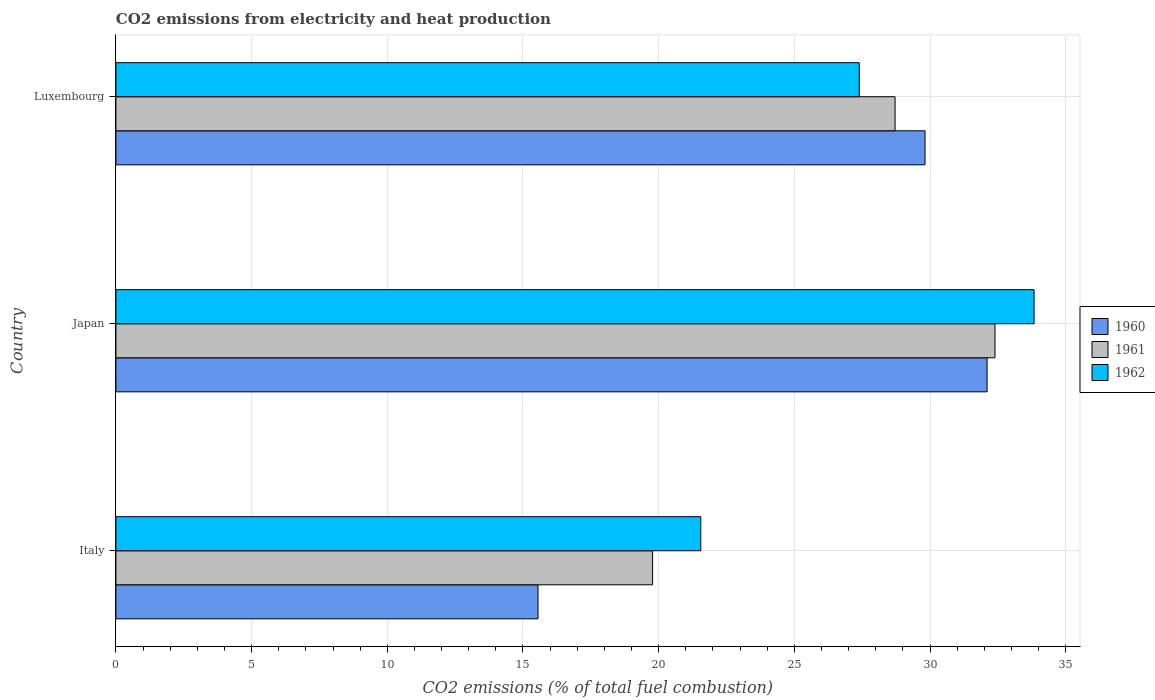How many groups of bars are there?
Your answer should be compact. 3. Are the number of bars per tick equal to the number of legend labels?
Offer a terse response. Yes. How many bars are there on the 3rd tick from the top?
Make the answer very short. 3. How many bars are there on the 2nd tick from the bottom?
Your answer should be compact. 3. What is the label of the 3rd group of bars from the top?
Your answer should be very brief. Italy. In how many cases, is the number of bars for a given country not equal to the number of legend labels?
Provide a short and direct response. 0. What is the amount of CO2 emitted in 1962 in Luxembourg?
Give a very brief answer. 27.39. Across all countries, what is the maximum amount of CO2 emitted in 1960?
Give a very brief answer. 32.1. Across all countries, what is the minimum amount of CO2 emitted in 1960?
Provide a short and direct response. 15.55. In which country was the amount of CO2 emitted in 1962 maximum?
Make the answer very short. Japan. What is the total amount of CO2 emitted in 1962 in the graph?
Your answer should be very brief. 82.78. What is the difference between the amount of CO2 emitted in 1960 in Italy and that in Japan?
Ensure brevity in your answer.  -16.55. What is the difference between the amount of CO2 emitted in 1960 in Italy and the amount of CO2 emitted in 1961 in Japan?
Your answer should be compact. -16.84. What is the average amount of CO2 emitted in 1962 per country?
Offer a terse response. 27.59. What is the difference between the amount of CO2 emitted in 1960 and amount of CO2 emitted in 1962 in Luxembourg?
Ensure brevity in your answer.  2.42. In how many countries, is the amount of CO2 emitted in 1961 greater than 28 %?
Your answer should be compact. 2. What is the ratio of the amount of CO2 emitted in 1962 in Italy to that in Japan?
Keep it short and to the point. 0.64. Is the amount of CO2 emitted in 1961 in Italy less than that in Luxembourg?
Make the answer very short. Yes. What is the difference between the highest and the second highest amount of CO2 emitted in 1962?
Provide a short and direct response. 6.44. What is the difference between the highest and the lowest amount of CO2 emitted in 1960?
Give a very brief answer. 16.55. In how many countries, is the amount of CO2 emitted in 1961 greater than the average amount of CO2 emitted in 1961 taken over all countries?
Ensure brevity in your answer.  2. What does the 1st bar from the top in Italy represents?
Ensure brevity in your answer.  1962. How many bars are there?
Make the answer very short. 9. How many countries are there in the graph?
Offer a terse response. 3. Are the values on the major ticks of X-axis written in scientific E-notation?
Provide a succinct answer. No. Does the graph contain any zero values?
Make the answer very short. No. Does the graph contain grids?
Your answer should be compact. Yes. Where does the legend appear in the graph?
Your answer should be very brief. Center right. What is the title of the graph?
Provide a short and direct response. CO2 emissions from electricity and heat production. Does "1993" appear as one of the legend labels in the graph?
Offer a very short reply. No. What is the label or title of the X-axis?
Your answer should be very brief. CO2 emissions (% of total fuel combustion). What is the label or title of the Y-axis?
Make the answer very short. Country. What is the CO2 emissions (% of total fuel combustion) of 1960 in Italy?
Offer a terse response. 15.55. What is the CO2 emissions (% of total fuel combustion) in 1961 in Italy?
Your response must be concise. 19.78. What is the CO2 emissions (% of total fuel combustion) in 1962 in Italy?
Offer a terse response. 21.55. What is the CO2 emissions (% of total fuel combustion) of 1960 in Japan?
Keep it short and to the point. 32.1. What is the CO2 emissions (% of total fuel combustion) of 1961 in Japan?
Keep it short and to the point. 32.39. What is the CO2 emissions (% of total fuel combustion) of 1962 in Japan?
Make the answer very short. 33.83. What is the CO2 emissions (% of total fuel combustion) of 1960 in Luxembourg?
Your response must be concise. 29.81. What is the CO2 emissions (% of total fuel combustion) of 1961 in Luxembourg?
Make the answer very short. 28.71. What is the CO2 emissions (% of total fuel combustion) in 1962 in Luxembourg?
Your response must be concise. 27.39. Across all countries, what is the maximum CO2 emissions (% of total fuel combustion) of 1960?
Your answer should be compact. 32.1. Across all countries, what is the maximum CO2 emissions (% of total fuel combustion) in 1961?
Ensure brevity in your answer.  32.39. Across all countries, what is the maximum CO2 emissions (% of total fuel combustion) in 1962?
Your answer should be compact. 33.83. Across all countries, what is the minimum CO2 emissions (% of total fuel combustion) in 1960?
Your answer should be very brief. 15.55. Across all countries, what is the minimum CO2 emissions (% of total fuel combustion) in 1961?
Keep it short and to the point. 19.78. Across all countries, what is the minimum CO2 emissions (% of total fuel combustion) in 1962?
Your response must be concise. 21.55. What is the total CO2 emissions (% of total fuel combustion) of 1960 in the graph?
Make the answer very short. 77.47. What is the total CO2 emissions (% of total fuel combustion) of 1961 in the graph?
Provide a short and direct response. 80.88. What is the total CO2 emissions (% of total fuel combustion) of 1962 in the graph?
Offer a terse response. 82.78. What is the difference between the CO2 emissions (% of total fuel combustion) of 1960 in Italy and that in Japan?
Keep it short and to the point. -16.55. What is the difference between the CO2 emissions (% of total fuel combustion) in 1961 in Italy and that in Japan?
Ensure brevity in your answer.  -12.62. What is the difference between the CO2 emissions (% of total fuel combustion) of 1962 in Italy and that in Japan?
Make the answer very short. -12.28. What is the difference between the CO2 emissions (% of total fuel combustion) of 1960 in Italy and that in Luxembourg?
Give a very brief answer. -14.26. What is the difference between the CO2 emissions (% of total fuel combustion) of 1961 in Italy and that in Luxembourg?
Make the answer very short. -8.93. What is the difference between the CO2 emissions (% of total fuel combustion) of 1962 in Italy and that in Luxembourg?
Keep it short and to the point. -5.84. What is the difference between the CO2 emissions (% of total fuel combustion) of 1960 in Japan and that in Luxembourg?
Keep it short and to the point. 2.29. What is the difference between the CO2 emissions (% of total fuel combustion) in 1961 in Japan and that in Luxembourg?
Provide a succinct answer. 3.68. What is the difference between the CO2 emissions (% of total fuel combustion) of 1962 in Japan and that in Luxembourg?
Make the answer very short. 6.44. What is the difference between the CO2 emissions (% of total fuel combustion) in 1960 in Italy and the CO2 emissions (% of total fuel combustion) in 1961 in Japan?
Provide a short and direct response. -16.84. What is the difference between the CO2 emissions (% of total fuel combustion) of 1960 in Italy and the CO2 emissions (% of total fuel combustion) of 1962 in Japan?
Give a very brief answer. -18.28. What is the difference between the CO2 emissions (% of total fuel combustion) in 1961 in Italy and the CO2 emissions (% of total fuel combustion) in 1962 in Japan?
Ensure brevity in your answer.  -14.06. What is the difference between the CO2 emissions (% of total fuel combustion) in 1960 in Italy and the CO2 emissions (% of total fuel combustion) in 1961 in Luxembourg?
Offer a very short reply. -13.16. What is the difference between the CO2 emissions (% of total fuel combustion) of 1960 in Italy and the CO2 emissions (% of total fuel combustion) of 1962 in Luxembourg?
Ensure brevity in your answer.  -11.84. What is the difference between the CO2 emissions (% of total fuel combustion) of 1961 in Italy and the CO2 emissions (% of total fuel combustion) of 1962 in Luxembourg?
Your answer should be very brief. -7.62. What is the difference between the CO2 emissions (% of total fuel combustion) in 1960 in Japan and the CO2 emissions (% of total fuel combustion) in 1961 in Luxembourg?
Offer a terse response. 3.39. What is the difference between the CO2 emissions (% of total fuel combustion) of 1960 in Japan and the CO2 emissions (% of total fuel combustion) of 1962 in Luxembourg?
Give a very brief answer. 4.71. What is the difference between the CO2 emissions (% of total fuel combustion) in 1961 in Japan and the CO2 emissions (% of total fuel combustion) in 1962 in Luxembourg?
Your answer should be compact. 5. What is the average CO2 emissions (% of total fuel combustion) in 1960 per country?
Keep it short and to the point. 25.82. What is the average CO2 emissions (% of total fuel combustion) in 1961 per country?
Your response must be concise. 26.96. What is the average CO2 emissions (% of total fuel combustion) in 1962 per country?
Provide a short and direct response. 27.59. What is the difference between the CO2 emissions (% of total fuel combustion) of 1960 and CO2 emissions (% of total fuel combustion) of 1961 in Italy?
Keep it short and to the point. -4.22. What is the difference between the CO2 emissions (% of total fuel combustion) of 1960 and CO2 emissions (% of total fuel combustion) of 1962 in Italy?
Keep it short and to the point. -6. What is the difference between the CO2 emissions (% of total fuel combustion) of 1961 and CO2 emissions (% of total fuel combustion) of 1962 in Italy?
Your answer should be very brief. -1.78. What is the difference between the CO2 emissions (% of total fuel combustion) of 1960 and CO2 emissions (% of total fuel combustion) of 1961 in Japan?
Provide a short and direct response. -0.29. What is the difference between the CO2 emissions (% of total fuel combustion) in 1960 and CO2 emissions (% of total fuel combustion) in 1962 in Japan?
Your answer should be compact. -1.73. What is the difference between the CO2 emissions (% of total fuel combustion) in 1961 and CO2 emissions (% of total fuel combustion) in 1962 in Japan?
Your response must be concise. -1.44. What is the difference between the CO2 emissions (% of total fuel combustion) of 1960 and CO2 emissions (% of total fuel combustion) of 1961 in Luxembourg?
Ensure brevity in your answer.  1.1. What is the difference between the CO2 emissions (% of total fuel combustion) in 1960 and CO2 emissions (% of total fuel combustion) in 1962 in Luxembourg?
Make the answer very short. 2.42. What is the difference between the CO2 emissions (% of total fuel combustion) in 1961 and CO2 emissions (% of total fuel combustion) in 1962 in Luxembourg?
Your response must be concise. 1.32. What is the ratio of the CO2 emissions (% of total fuel combustion) in 1960 in Italy to that in Japan?
Your answer should be compact. 0.48. What is the ratio of the CO2 emissions (% of total fuel combustion) in 1961 in Italy to that in Japan?
Ensure brevity in your answer.  0.61. What is the ratio of the CO2 emissions (% of total fuel combustion) in 1962 in Italy to that in Japan?
Ensure brevity in your answer.  0.64. What is the ratio of the CO2 emissions (% of total fuel combustion) of 1960 in Italy to that in Luxembourg?
Make the answer very short. 0.52. What is the ratio of the CO2 emissions (% of total fuel combustion) of 1961 in Italy to that in Luxembourg?
Offer a very short reply. 0.69. What is the ratio of the CO2 emissions (% of total fuel combustion) in 1962 in Italy to that in Luxembourg?
Offer a terse response. 0.79. What is the ratio of the CO2 emissions (% of total fuel combustion) in 1960 in Japan to that in Luxembourg?
Your answer should be compact. 1.08. What is the ratio of the CO2 emissions (% of total fuel combustion) of 1961 in Japan to that in Luxembourg?
Give a very brief answer. 1.13. What is the ratio of the CO2 emissions (% of total fuel combustion) in 1962 in Japan to that in Luxembourg?
Provide a short and direct response. 1.24. What is the difference between the highest and the second highest CO2 emissions (% of total fuel combustion) in 1960?
Provide a succinct answer. 2.29. What is the difference between the highest and the second highest CO2 emissions (% of total fuel combustion) of 1961?
Make the answer very short. 3.68. What is the difference between the highest and the second highest CO2 emissions (% of total fuel combustion) in 1962?
Keep it short and to the point. 6.44. What is the difference between the highest and the lowest CO2 emissions (% of total fuel combustion) in 1960?
Provide a short and direct response. 16.55. What is the difference between the highest and the lowest CO2 emissions (% of total fuel combustion) in 1961?
Your answer should be very brief. 12.62. What is the difference between the highest and the lowest CO2 emissions (% of total fuel combustion) of 1962?
Keep it short and to the point. 12.28. 